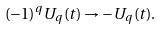Convert formula to latex. <formula><loc_0><loc_0><loc_500><loc_500>( - 1 ) ^ { q } U _ { q } ( t ) \rightarrow - U _ { q } ( t ) .</formula> 